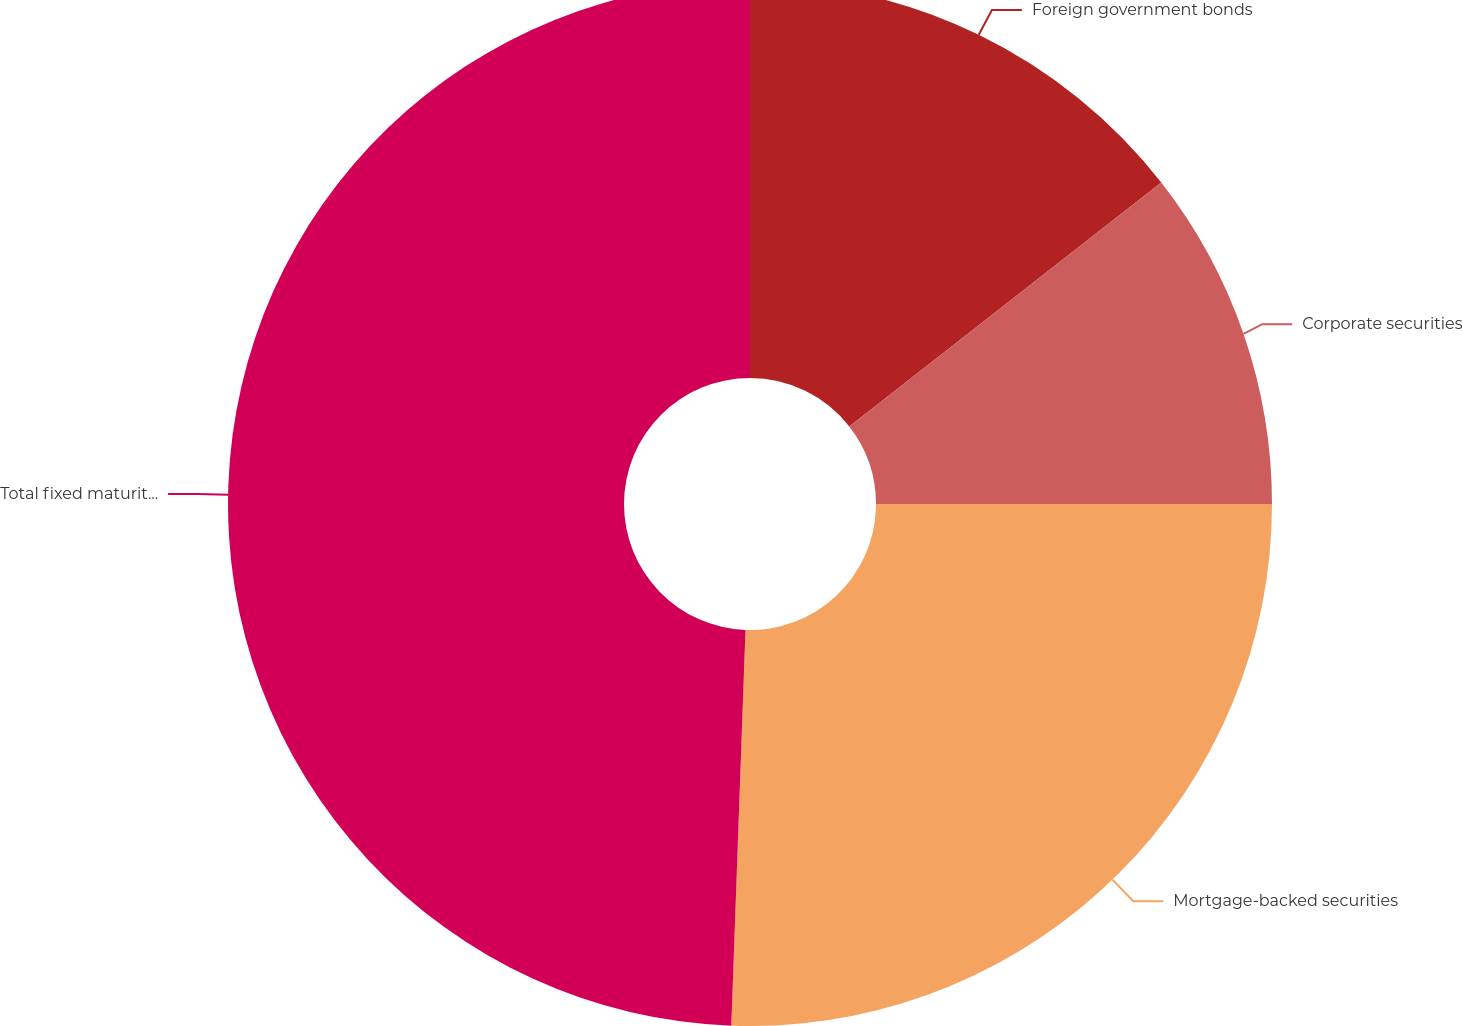Convert chart to OTSL. <chart><loc_0><loc_0><loc_500><loc_500><pie_chart><fcel>Foreign government bonds<fcel>Corporate securities<fcel>Mortgage-backed securities<fcel>Total fixed maturities held to<nl><fcel>14.44%<fcel>10.56%<fcel>25.57%<fcel>49.43%<nl></chart> 